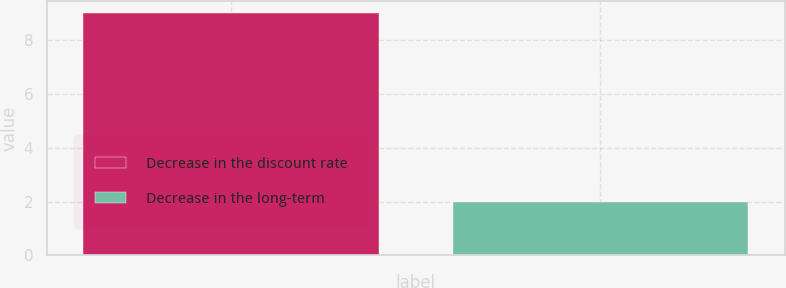Convert chart. <chart><loc_0><loc_0><loc_500><loc_500><bar_chart><fcel>Decrease in the discount rate<fcel>Decrease in the long-term<nl><fcel>9<fcel>2<nl></chart> 